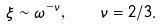<formula> <loc_0><loc_0><loc_500><loc_500>\xi \sim \omega ^ { - \nu } , \quad \nu = 2 / 3 .</formula> 